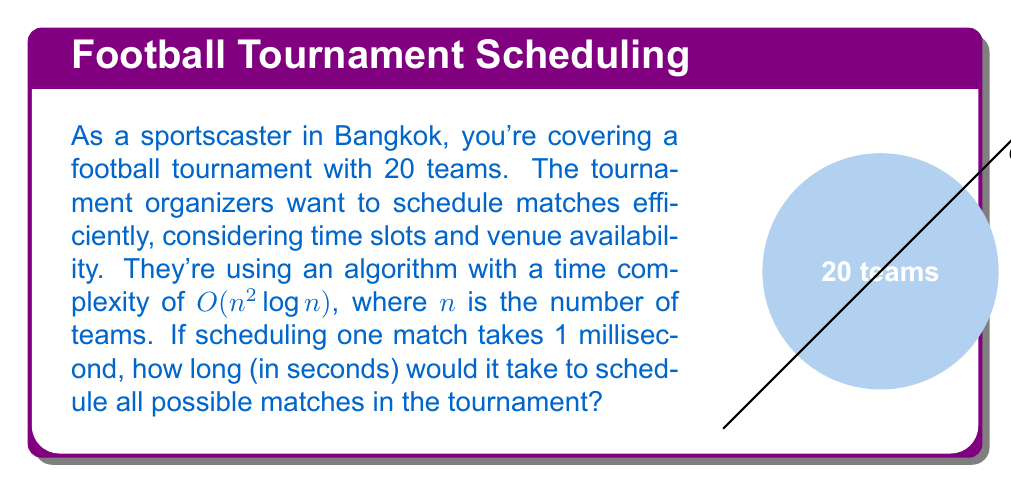Provide a solution to this math problem. Let's approach this step-by-step:

1) First, we need to calculate the number of possible matches. With 20 teams, each team plays against every other team once. The formula for this is:

   $$\text{Number of matches} = \frac{n(n-1)}{2}$$

   Where $n$ is the number of teams.

2) Plugging in $n = 20$:

   $$\text{Number of matches} = \frac{20(20-1)}{2} = \frac{20 \cdot 19}{2} = 190$$

3) Now, the time complexity is $O(n^2 \log n)$. This means the actual time taken will be proportional to $n^2 \log n$. Let's calculate this:

   $$20^2 \log 20 = 400 \cdot \log 20 \approx 400 \cdot 2.9957 \approx 1198.28$$

4) If scheduling one match takes 1 millisecond, then scheduling all matches will take:

   $$1198.28 \text{ milliseconds}$$

5) To convert this to seconds, we divide by 1000:

   $$1198.28 / 1000 \approx 1.19828 \text{ seconds}$$
Answer: $\approx 1.20$ seconds 